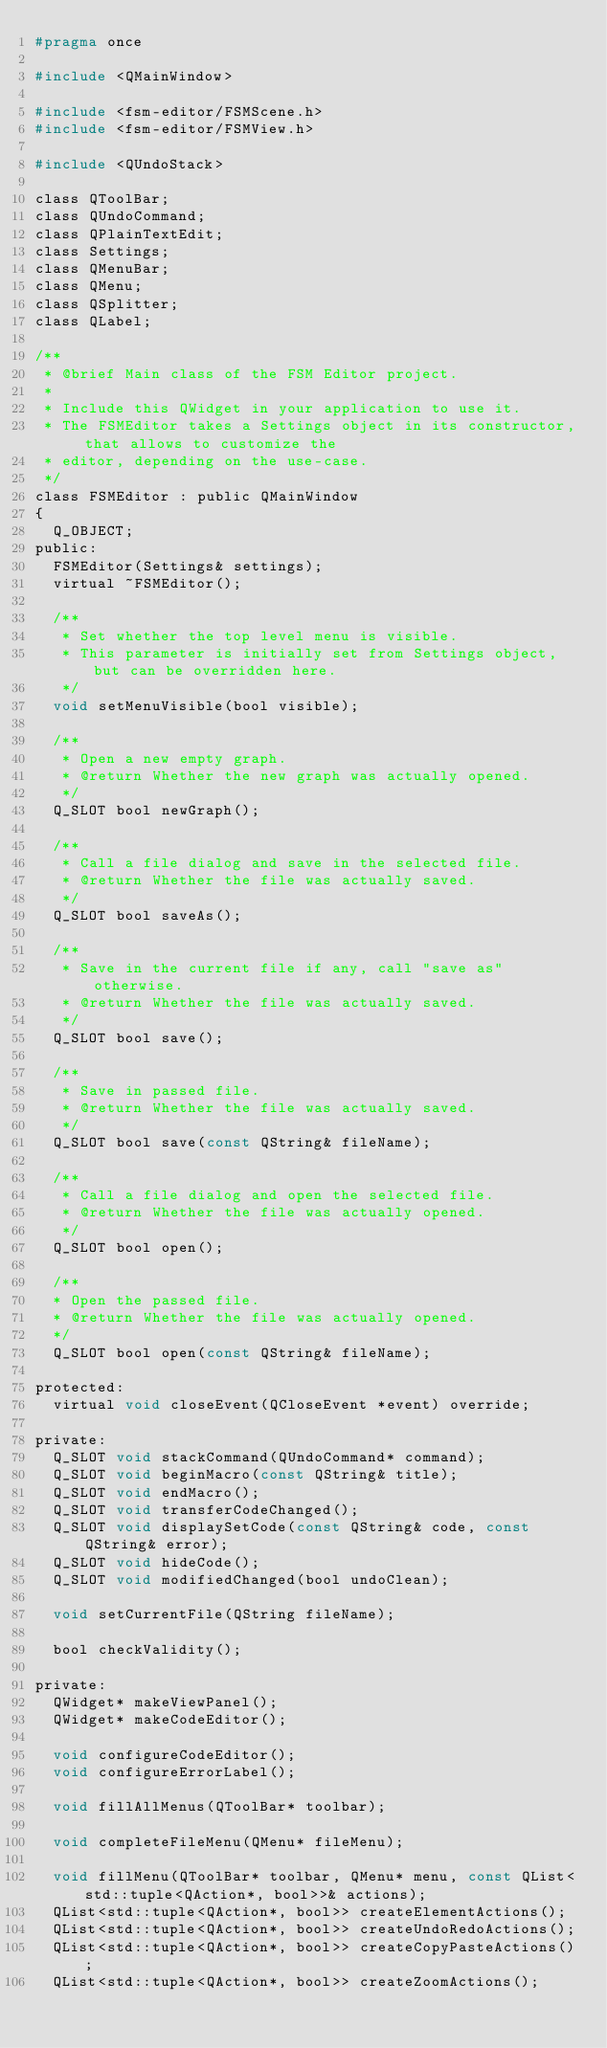Convert code to text. <code><loc_0><loc_0><loc_500><loc_500><_C_>#pragma once

#include <QMainWindow>

#include <fsm-editor/FSMScene.h>
#include <fsm-editor/FSMView.h>

#include <QUndoStack>

class QToolBar;
class QUndoCommand;
class QPlainTextEdit;
class Settings;
class QMenuBar;
class QMenu;
class QSplitter;
class QLabel;

/**
 * @brief Main class of the FSM Editor project.
 *
 * Include this QWidget in your application to use it.
 * The FSMEditor takes a Settings object in its constructor, that allows to customize the
 * editor, depending on the use-case.
 */
class FSMEditor : public QMainWindow
{
  Q_OBJECT;
public:
  FSMEditor(Settings& settings);
  virtual ~FSMEditor();

  /**
   * Set whether the top level menu is visible.
   * This parameter is initially set from Settings object, but can be overridden here.
   */
  void setMenuVisible(bool visible);

  /**
   * Open a new empty graph.
   * @return Whether the new graph was actually opened.
   */
  Q_SLOT bool newGraph();

  /**
   * Call a file dialog and save in the selected file.
   * @return Whether the file was actually saved.
   */
  Q_SLOT bool saveAs();

  /**
   * Save in the current file if any, call "save as" otherwise.
   * @return Whether the file was actually saved.
   */
  Q_SLOT bool save();

  /**
   * Save in passed file.
   * @return Whether the file was actually saved.
   */
  Q_SLOT bool save(const QString& fileName);

  /**
   * Call a file dialog and open the selected file.
   * @return Whether the file was actually opened.
   */
  Q_SLOT bool open();

  /**
  * Open the passed file.
  * @return Whether the file was actually opened.
  */
  Q_SLOT bool open(const QString& fileName);

protected:
  virtual void closeEvent(QCloseEvent *event) override;

private:
  Q_SLOT void stackCommand(QUndoCommand* command);
  Q_SLOT void beginMacro(const QString& title);
  Q_SLOT void endMacro();
  Q_SLOT void transferCodeChanged();
  Q_SLOT void displaySetCode(const QString& code, const QString& error);
  Q_SLOT void hideCode();
  Q_SLOT void modifiedChanged(bool undoClean);

  void setCurrentFile(QString fileName);

  bool checkValidity();

private:
  QWidget* makeViewPanel();
  QWidget* makeCodeEditor();

  void configureCodeEditor();
  void configureErrorLabel();

  void fillAllMenus(QToolBar* toolbar);

  void completeFileMenu(QMenu* fileMenu);

  void fillMenu(QToolBar* toolbar, QMenu* menu, const QList<std::tuple<QAction*, bool>>& actions);
  QList<std::tuple<QAction*, bool>> createElementActions();
  QList<std::tuple<QAction*, bool>> createUndoRedoActions();
  QList<std::tuple<QAction*, bool>> createCopyPasteActions();
  QList<std::tuple<QAction*, bool>> createZoomActions();</code> 